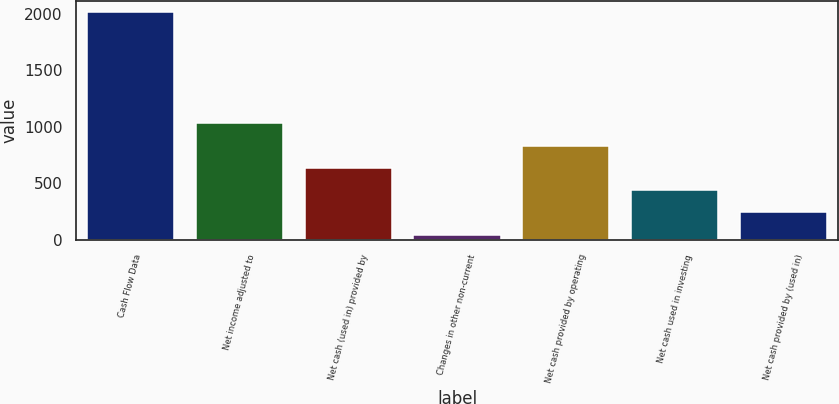Convert chart to OTSL. <chart><loc_0><loc_0><loc_500><loc_500><bar_chart><fcel>Cash Flow Data<fcel>Net income adjusted to<fcel>Net cash (used in) provided by<fcel>Changes in other non-current<fcel>Net cash provided by operating<fcel>Net cash used in investing<fcel>Net cash provided by (used in)<nl><fcel>2012<fcel>1029.4<fcel>636.36<fcel>46.8<fcel>832.88<fcel>439.84<fcel>243.32<nl></chart> 